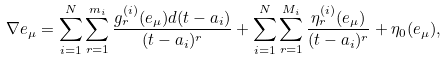<formula> <loc_0><loc_0><loc_500><loc_500>\nabla e _ { \mu } = \sum _ { i = 1 } ^ { N } \sum _ { r = 1 } ^ { m _ { i } } \frac { g _ { r } ^ { ( i ) } ( e _ { \mu } ) d ( t - a _ { i } ) } { ( t - a _ { i } ) ^ { r } } + \sum _ { i = 1 } ^ { N } \sum _ { r = 1 } ^ { M _ { i } } \frac { \eta ^ { ( i ) } _ { r } ( e _ { \mu } ) } { ( t - a _ { i } ) ^ { r } } + \eta _ { 0 } ( e _ { \mu } ) ,</formula> 